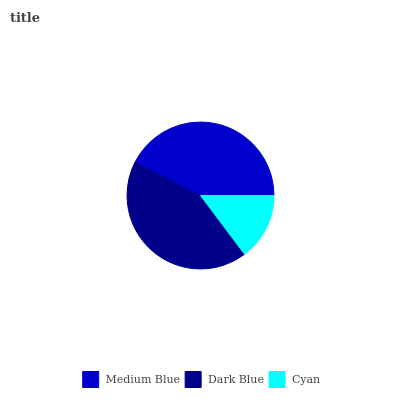Is Cyan the minimum?
Answer yes or no. Yes. Is Dark Blue the maximum?
Answer yes or no. Yes. Is Dark Blue the minimum?
Answer yes or no. No. Is Cyan the maximum?
Answer yes or no. No. Is Dark Blue greater than Cyan?
Answer yes or no. Yes. Is Cyan less than Dark Blue?
Answer yes or no. Yes. Is Cyan greater than Dark Blue?
Answer yes or no. No. Is Dark Blue less than Cyan?
Answer yes or no. No. Is Medium Blue the high median?
Answer yes or no. Yes. Is Medium Blue the low median?
Answer yes or no. Yes. Is Cyan the high median?
Answer yes or no. No. Is Dark Blue the low median?
Answer yes or no. No. 